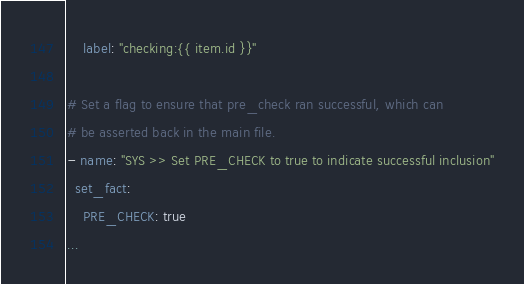<code> <loc_0><loc_0><loc_500><loc_500><_YAML_>    label: "checking:{{ item.id }}"

# Set a flag to ensure that pre_check ran successful, which can
# be asserted back in the main file.
- name: "SYS >> Set PRE_CHECK to true to indicate successful inclusion"
  set_fact:
    PRE_CHECK: true
...
</code> 